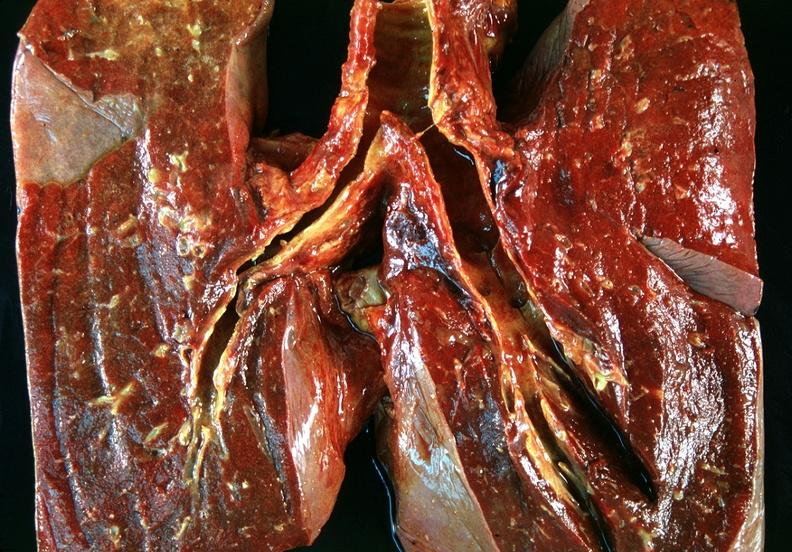does diagnosis show lung, bronchitis and oxygen toxicity with hyaline membranes?
Answer the question using a single word or phrase. No 